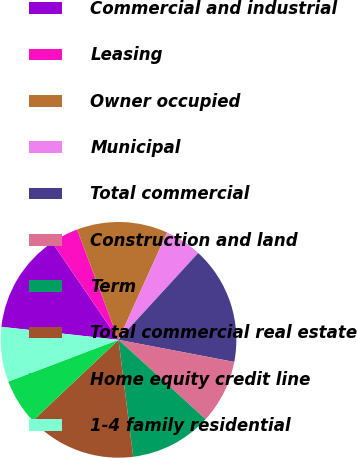<chart> <loc_0><loc_0><loc_500><loc_500><pie_chart><fcel>Commercial and industrial<fcel>Leasing<fcel>Owner occupied<fcel>Municipal<fcel>Total commercial<fcel>Construction and land<fcel>Term<fcel>Total commercial real estate<fcel>Home equity credit line<fcel>1-4 family residential<nl><fcel>13.72%<fcel>3.81%<fcel>12.48%<fcel>5.05%<fcel>16.19%<fcel>8.76%<fcel>11.24%<fcel>14.95%<fcel>6.28%<fcel>7.52%<nl></chart> 